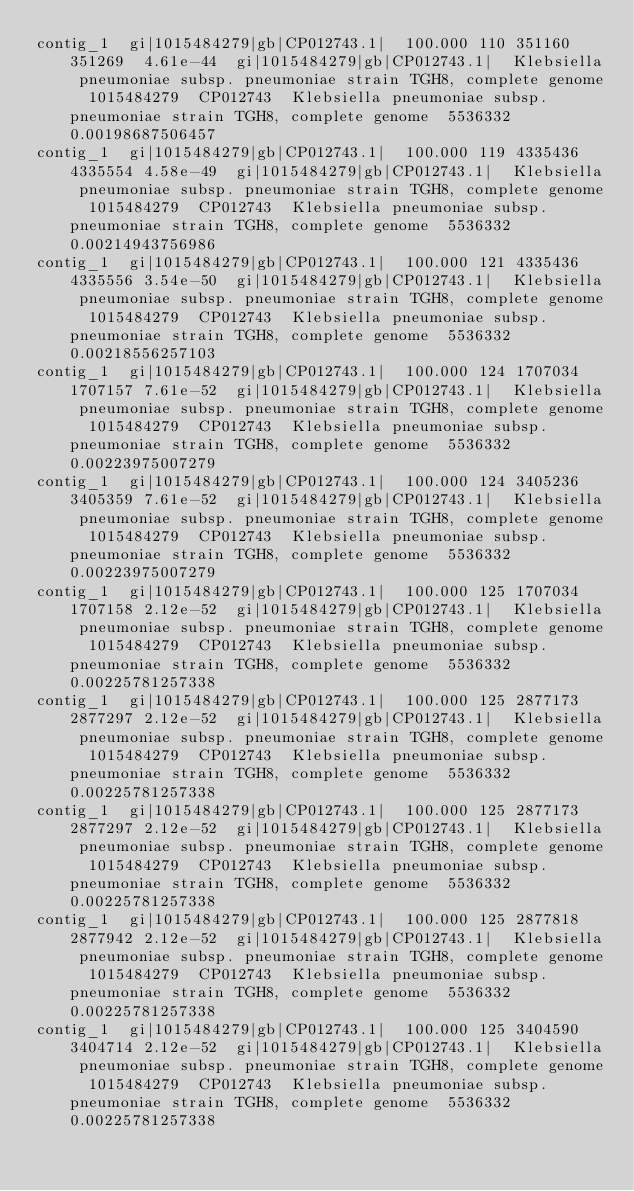<code> <loc_0><loc_0><loc_500><loc_500><_SQL_>contig_1	gi|1015484279|gb|CP012743.1|	100.000	110	351160	351269	4.61e-44	gi|1015484279|gb|CP012743.1|	Klebsiella pneumoniae subsp. pneumoniae strain TGH8, complete genome	1015484279	CP012743	Klebsiella pneumoniae subsp. pneumoniae strain TGH8, complete genome	5536332	0.00198687506457
contig_1	gi|1015484279|gb|CP012743.1|	100.000	119	4335436	4335554	4.58e-49	gi|1015484279|gb|CP012743.1|	Klebsiella pneumoniae subsp. pneumoniae strain TGH8, complete genome	1015484279	CP012743	Klebsiella pneumoniae subsp. pneumoniae strain TGH8, complete genome	5536332	0.00214943756986
contig_1	gi|1015484279|gb|CP012743.1|	100.000	121	4335436	4335556	3.54e-50	gi|1015484279|gb|CP012743.1|	Klebsiella pneumoniae subsp. pneumoniae strain TGH8, complete genome	1015484279	CP012743	Klebsiella pneumoniae subsp. pneumoniae strain TGH8, complete genome	5536332	0.00218556257103
contig_1	gi|1015484279|gb|CP012743.1|	100.000	124	1707034	1707157	7.61e-52	gi|1015484279|gb|CP012743.1|	Klebsiella pneumoniae subsp. pneumoniae strain TGH8, complete genome	1015484279	CP012743	Klebsiella pneumoniae subsp. pneumoniae strain TGH8, complete genome	5536332	0.00223975007279
contig_1	gi|1015484279|gb|CP012743.1|	100.000	124	3405236	3405359	7.61e-52	gi|1015484279|gb|CP012743.1|	Klebsiella pneumoniae subsp. pneumoniae strain TGH8, complete genome	1015484279	CP012743	Klebsiella pneumoniae subsp. pneumoniae strain TGH8, complete genome	5536332	0.00223975007279
contig_1	gi|1015484279|gb|CP012743.1|	100.000	125	1707034	1707158	2.12e-52	gi|1015484279|gb|CP012743.1|	Klebsiella pneumoniae subsp. pneumoniae strain TGH8, complete genome	1015484279	CP012743	Klebsiella pneumoniae subsp. pneumoniae strain TGH8, complete genome	5536332	0.00225781257338
contig_1	gi|1015484279|gb|CP012743.1|	100.000	125	2877173	2877297	2.12e-52	gi|1015484279|gb|CP012743.1|	Klebsiella pneumoniae subsp. pneumoniae strain TGH8, complete genome	1015484279	CP012743	Klebsiella pneumoniae subsp. pneumoniae strain TGH8, complete genome	5536332	0.00225781257338
contig_1	gi|1015484279|gb|CP012743.1|	100.000	125	2877173	2877297	2.12e-52	gi|1015484279|gb|CP012743.1|	Klebsiella pneumoniae subsp. pneumoniae strain TGH8, complete genome	1015484279	CP012743	Klebsiella pneumoniae subsp. pneumoniae strain TGH8, complete genome	5536332	0.00225781257338
contig_1	gi|1015484279|gb|CP012743.1|	100.000	125	2877818	2877942	2.12e-52	gi|1015484279|gb|CP012743.1|	Klebsiella pneumoniae subsp. pneumoniae strain TGH8, complete genome	1015484279	CP012743	Klebsiella pneumoniae subsp. pneumoniae strain TGH8, complete genome	5536332	0.00225781257338
contig_1	gi|1015484279|gb|CP012743.1|	100.000	125	3404590	3404714	2.12e-52	gi|1015484279|gb|CP012743.1|	Klebsiella pneumoniae subsp. pneumoniae strain TGH8, complete genome	1015484279	CP012743	Klebsiella pneumoniae subsp. pneumoniae strain TGH8, complete genome	5536332	0.00225781257338
</code> 